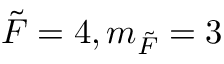Convert formula to latex. <formula><loc_0><loc_0><loc_500><loc_500>\tilde { F } = 4 , m _ { \tilde { F } } = 3</formula> 